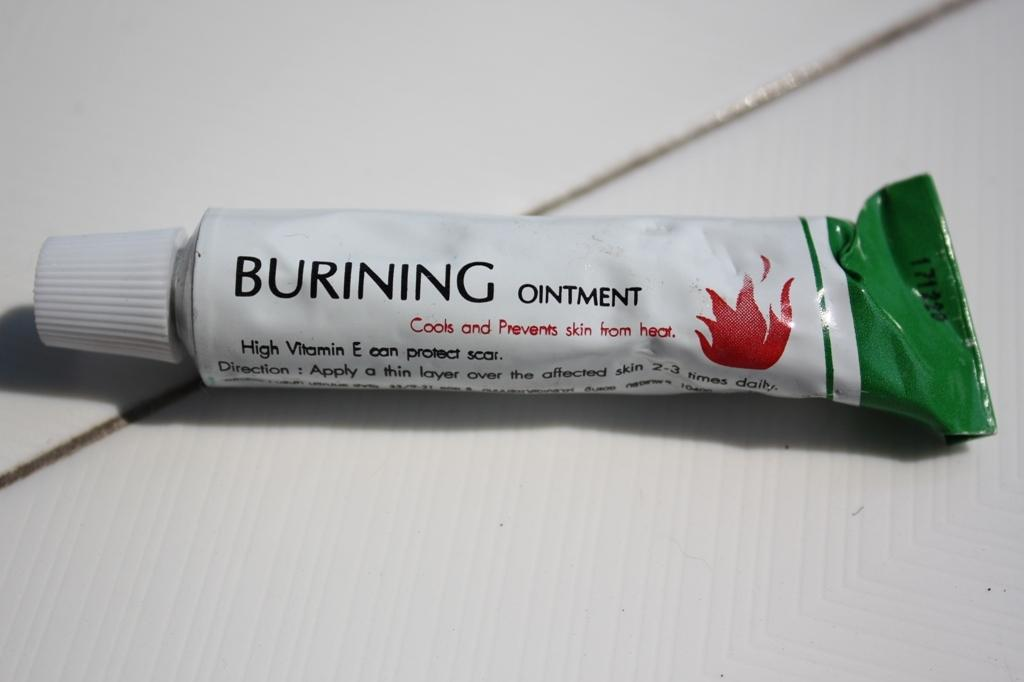<image>
Give a short and clear explanation of the subsequent image. A green and white tube of cream that says Burning ointment 